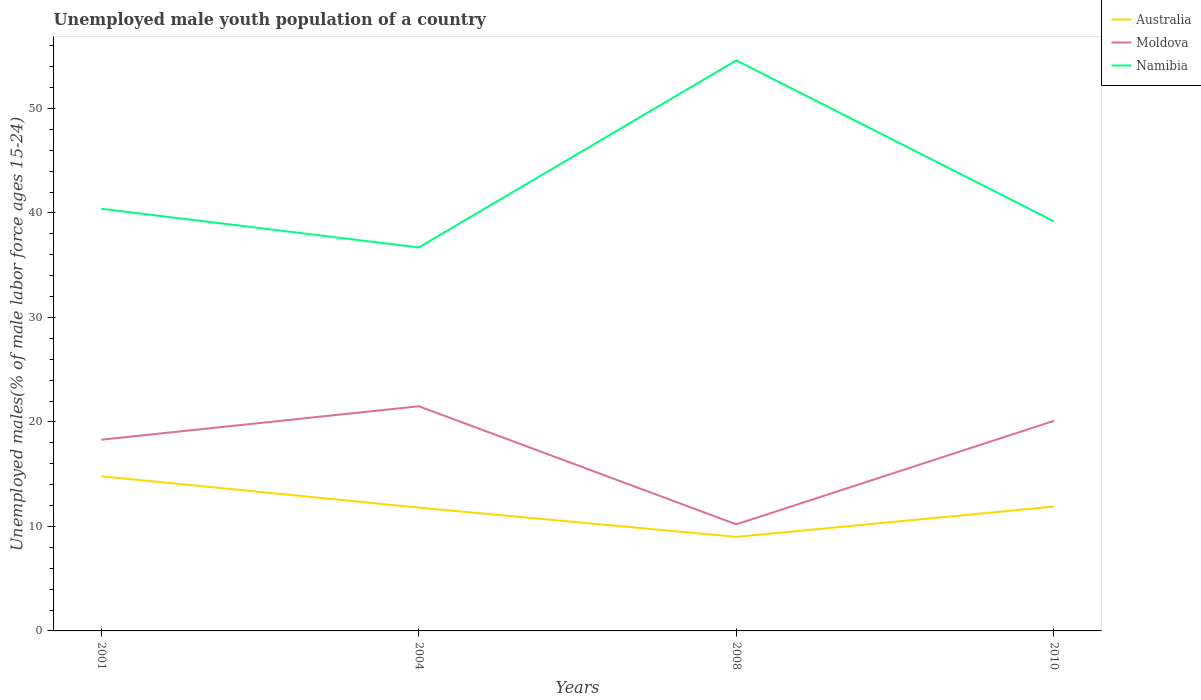How many different coloured lines are there?
Your answer should be very brief. 3. Across all years, what is the maximum percentage of unemployed male youth population in Namibia?
Provide a succinct answer. 36.7. What is the total percentage of unemployed male youth population in Australia in the graph?
Make the answer very short. 2.8. What is the difference between the highest and the second highest percentage of unemployed male youth population in Australia?
Make the answer very short. 5.8. How many lines are there?
Keep it short and to the point. 3. How many years are there in the graph?
Your answer should be very brief. 4. What is the difference between two consecutive major ticks on the Y-axis?
Your answer should be very brief. 10. Where does the legend appear in the graph?
Your response must be concise. Top right. How are the legend labels stacked?
Give a very brief answer. Vertical. What is the title of the graph?
Your answer should be compact. Unemployed male youth population of a country. What is the label or title of the Y-axis?
Give a very brief answer. Unemployed males(% of male labor force ages 15-24). What is the Unemployed males(% of male labor force ages 15-24) of Australia in 2001?
Make the answer very short. 14.8. What is the Unemployed males(% of male labor force ages 15-24) of Moldova in 2001?
Your response must be concise. 18.3. What is the Unemployed males(% of male labor force ages 15-24) of Namibia in 2001?
Keep it short and to the point. 40.4. What is the Unemployed males(% of male labor force ages 15-24) of Australia in 2004?
Your response must be concise. 11.8. What is the Unemployed males(% of male labor force ages 15-24) in Moldova in 2004?
Your response must be concise. 21.5. What is the Unemployed males(% of male labor force ages 15-24) in Namibia in 2004?
Give a very brief answer. 36.7. What is the Unemployed males(% of male labor force ages 15-24) of Australia in 2008?
Provide a short and direct response. 9. What is the Unemployed males(% of male labor force ages 15-24) in Moldova in 2008?
Your response must be concise. 10.2. What is the Unemployed males(% of male labor force ages 15-24) in Namibia in 2008?
Ensure brevity in your answer.  54.6. What is the Unemployed males(% of male labor force ages 15-24) of Australia in 2010?
Give a very brief answer. 11.9. What is the Unemployed males(% of male labor force ages 15-24) of Moldova in 2010?
Give a very brief answer. 20.1. What is the Unemployed males(% of male labor force ages 15-24) in Namibia in 2010?
Ensure brevity in your answer.  39.2. Across all years, what is the maximum Unemployed males(% of male labor force ages 15-24) in Australia?
Make the answer very short. 14.8. Across all years, what is the maximum Unemployed males(% of male labor force ages 15-24) in Namibia?
Your response must be concise. 54.6. Across all years, what is the minimum Unemployed males(% of male labor force ages 15-24) of Australia?
Offer a very short reply. 9. Across all years, what is the minimum Unemployed males(% of male labor force ages 15-24) in Moldova?
Provide a succinct answer. 10.2. Across all years, what is the minimum Unemployed males(% of male labor force ages 15-24) of Namibia?
Your answer should be very brief. 36.7. What is the total Unemployed males(% of male labor force ages 15-24) of Australia in the graph?
Give a very brief answer. 47.5. What is the total Unemployed males(% of male labor force ages 15-24) of Moldova in the graph?
Provide a short and direct response. 70.1. What is the total Unemployed males(% of male labor force ages 15-24) in Namibia in the graph?
Your response must be concise. 170.9. What is the difference between the Unemployed males(% of male labor force ages 15-24) of Australia in 2001 and that in 2004?
Provide a succinct answer. 3. What is the difference between the Unemployed males(% of male labor force ages 15-24) of Moldova in 2001 and that in 2004?
Provide a succinct answer. -3.2. What is the difference between the Unemployed males(% of male labor force ages 15-24) of Namibia in 2001 and that in 2004?
Give a very brief answer. 3.7. What is the difference between the Unemployed males(% of male labor force ages 15-24) of Australia in 2001 and that in 2008?
Your answer should be compact. 5.8. What is the difference between the Unemployed males(% of male labor force ages 15-24) of Moldova in 2001 and that in 2008?
Make the answer very short. 8.1. What is the difference between the Unemployed males(% of male labor force ages 15-24) in Namibia in 2001 and that in 2008?
Ensure brevity in your answer.  -14.2. What is the difference between the Unemployed males(% of male labor force ages 15-24) in Moldova in 2001 and that in 2010?
Give a very brief answer. -1.8. What is the difference between the Unemployed males(% of male labor force ages 15-24) of Namibia in 2001 and that in 2010?
Your answer should be compact. 1.2. What is the difference between the Unemployed males(% of male labor force ages 15-24) in Australia in 2004 and that in 2008?
Provide a short and direct response. 2.8. What is the difference between the Unemployed males(% of male labor force ages 15-24) in Namibia in 2004 and that in 2008?
Your response must be concise. -17.9. What is the difference between the Unemployed males(% of male labor force ages 15-24) of Moldova in 2004 and that in 2010?
Give a very brief answer. 1.4. What is the difference between the Unemployed males(% of male labor force ages 15-24) of Namibia in 2004 and that in 2010?
Offer a terse response. -2.5. What is the difference between the Unemployed males(% of male labor force ages 15-24) of Australia in 2008 and that in 2010?
Offer a very short reply. -2.9. What is the difference between the Unemployed males(% of male labor force ages 15-24) of Namibia in 2008 and that in 2010?
Provide a short and direct response. 15.4. What is the difference between the Unemployed males(% of male labor force ages 15-24) in Australia in 2001 and the Unemployed males(% of male labor force ages 15-24) in Namibia in 2004?
Provide a short and direct response. -21.9. What is the difference between the Unemployed males(% of male labor force ages 15-24) in Moldova in 2001 and the Unemployed males(% of male labor force ages 15-24) in Namibia in 2004?
Provide a short and direct response. -18.4. What is the difference between the Unemployed males(% of male labor force ages 15-24) in Australia in 2001 and the Unemployed males(% of male labor force ages 15-24) in Moldova in 2008?
Provide a short and direct response. 4.6. What is the difference between the Unemployed males(% of male labor force ages 15-24) in Australia in 2001 and the Unemployed males(% of male labor force ages 15-24) in Namibia in 2008?
Your answer should be compact. -39.8. What is the difference between the Unemployed males(% of male labor force ages 15-24) of Moldova in 2001 and the Unemployed males(% of male labor force ages 15-24) of Namibia in 2008?
Make the answer very short. -36.3. What is the difference between the Unemployed males(% of male labor force ages 15-24) of Australia in 2001 and the Unemployed males(% of male labor force ages 15-24) of Namibia in 2010?
Give a very brief answer. -24.4. What is the difference between the Unemployed males(% of male labor force ages 15-24) of Moldova in 2001 and the Unemployed males(% of male labor force ages 15-24) of Namibia in 2010?
Your answer should be compact. -20.9. What is the difference between the Unemployed males(% of male labor force ages 15-24) of Australia in 2004 and the Unemployed males(% of male labor force ages 15-24) of Moldova in 2008?
Ensure brevity in your answer.  1.6. What is the difference between the Unemployed males(% of male labor force ages 15-24) of Australia in 2004 and the Unemployed males(% of male labor force ages 15-24) of Namibia in 2008?
Provide a short and direct response. -42.8. What is the difference between the Unemployed males(% of male labor force ages 15-24) in Moldova in 2004 and the Unemployed males(% of male labor force ages 15-24) in Namibia in 2008?
Your response must be concise. -33.1. What is the difference between the Unemployed males(% of male labor force ages 15-24) of Australia in 2004 and the Unemployed males(% of male labor force ages 15-24) of Moldova in 2010?
Ensure brevity in your answer.  -8.3. What is the difference between the Unemployed males(% of male labor force ages 15-24) of Australia in 2004 and the Unemployed males(% of male labor force ages 15-24) of Namibia in 2010?
Provide a short and direct response. -27.4. What is the difference between the Unemployed males(% of male labor force ages 15-24) of Moldova in 2004 and the Unemployed males(% of male labor force ages 15-24) of Namibia in 2010?
Give a very brief answer. -17.7. What is the difference between the Unemployed males(% of male labor force ages 15-24) of Australia in 2008 and the Unemployed males(% of male labor force ages 15-24) of Namibia in 2010?
Your answer should be compact. -30.2. What is the difference between the Unemployed males(% of male labor force ages 15-24) in Moldova in 2008 and the Unemployed males(% of male labor force ages 15-24) in Namibia in 2010?
Offer a very short reply. -29. What is the average Unemployed males(% of male labor force ages 15-24) of Australia per year?
Ensure brevity in your answer.  11.88. What is the average Unemployed males(% of male labor force ages 15-24) in Moldova per year?
Offer a very short reply. 17.52. What is the average Unemployed males(% of male labor force ages 15-24) of Namibia per year?
Offer a very short reply. 42.73. In the year 2001, what is the difference between the Unemployed males(% of male labor force ages 15-24) of Australia and Unemployed males(% of male labor force ages 15-24) of Namibia?
Keep it short and to the point. -25.6. In the year 2001, what is the difference between the Unemployed males(% of male labor force ages 15-24) in Moldova and Unemployed males(% of male labor force ages 15-24) in Namibia?
Your answer should be compact. -22.1. In the year 2004, what is the difference between the Unemployed males(% of male labor force ages 15-24) in Australia and Unemployed males(% of male labor force ages 15-24) in Moldova?
Provide a succinct answer. -9.7. In the year 2004, what is the difference between the Unemployed males(% of male labor force ages 15-24) of Australia and Unemployed males(% of male labor force ages 15-24) of Namibia?
Offer a terse response. -24.9. In the year 2004, what is the difference between the Unemployed males(% of male labor force ages 15-24) in Moldova and Unemployed males(% of male labor force ages 15-24) in Namibia?
Give a very brief answer. -15.2. In the year 2008, what is the difference between the Unemployed males(% of male labor force ages 15-24) of Australia and Unemployed males(% of male labor force ages 15-24) of Moldova?
Offer a very short reply. -1.2. In the year 2008, what is the difference between the Unemployed males(% of male labor force ages 15-24) in Australia and Unemployed males(% of male labor force ages 15-24) in Namibia?
Offer a terse response. -45.6. In the year 2008, what is the difference between the Unemployed males(% of male labor force ages 15-24) of Moldova and Unemployed males(% of male labor force ages 15-24) of Namibia?
Your response must be concise. -44.4. In the year 2010, what is the difference between the Unemployed males(% of male labor force ages 15-24) of Australia and Unemployed males(% of male labor force ages 15-24) of Namibia?
Give a very brief answer. -27.3. In the year 2010, what is the difference between the Unemployed males(% of male labor force ages 15-24) in Moldova and Unemployed males(% of male labor force ages 15-24) in Namibia?
Provide a succinct answer. -19.1. What is the ratio of the Unemployed males(% of male labor force ages 15-24) of Australia in 2001 to that in 2004?
Give a very brief answer. 1.25. What is the ratio of the Unemployed males(% of male labor force ages 15-24) of Moldova in 2001 to that in 2004?
Provide a short and direct response. 0.85. What is the ratio of the Unemployed males(% of male labor force ages 15-24) of Namibia in 2001 to that in 2004?
Offer a terse response. 1.1. What is the ratio of the Unemployed males(% of male labor force ages 15-24) in Australia in 2001 to that in 2008?
Provide a succinct answer. 1.64. What is the ratio of the Unemployed males(% of male labor force ages 15-24) in Moldova in 2001 to that in 2008?
Provide a short and direct response. 1.79. What is the ratio of the Unemployed males(% of male labor force ages 15-24) in Namibia in 2001 to that in 2008?
Keep it short and to the point. 0.74. What is the ratio of the Unemployed males(% of male labor force ages 15-24) of Australia in 2001 to that in 2010?
Give a very brief answer. 1.24. What is the ratio of the Unemployed males(% of male labor force ages 15-24) in Moldova in 2001 to that in 2010?
Keep it short and to the point. 0.91. What is the ratio of the Unemployed males(% of male labor force ages 15-24) of Namibia in 2001 to that in 2010?
Offer a very short reply. 1.03. What is the ratio of the Unemployed males(% of male labor force ages 15-24) in Australia in 2004 to that in 2008?
Give a very brief answer. 1.31. What is the ratio of the Unemployed males(% of male labor force ages 15-24) in Moldova in 2004 to that in 2008?
Offer a terse response. 2.11. What is the ratio of the Unemployed males(% of male labor force ages 15-24) of Namibia in 2004 to that in 2008?
Ensure brevity in your answer.  0.67. What is the ratio of the Unemployed males(% of male labor force ages 15-24) of Moldova in 2004 to that in 2010?
Your response must be concise. 1.07. What is the ratio of the Unemployed males(% of male labor force ages 15-24) in Namibia in 2004 to that in 2010?
Offer a very short reply. 0.94. What is the ratio of the Unemployed males(% of male labor force ages 15-24) in Australia in 2008 to that in 2010?
Provide a succinct answer. 0.76. What is the ratio of the Unemployed males(% of male labor force ages 15-24) in Moldova in 2008 to that in 2010?
Your answer should be compact. 0.51. What is the ratio of the Unemployed males(% of male labor force ages 15-24) of Namibia in 2008 to that in 2010?
Provide a short and direct response. 1.39. What is the difference between the highest and the second highest Unemployed males(% of male labor force ages 15-24) in Namibia?
Offer a terse response. 14.2. What is the difference between the highest and the lowest Unemployed males(% of male labor force ages 15-24) of Australia?
Your response must be concise. 5.8. What is the difference between the highest and the lowest Unemployed males(% of male labor force ages 15-24) of Moldova?
Ensure brevity in your answer.  11.3. 